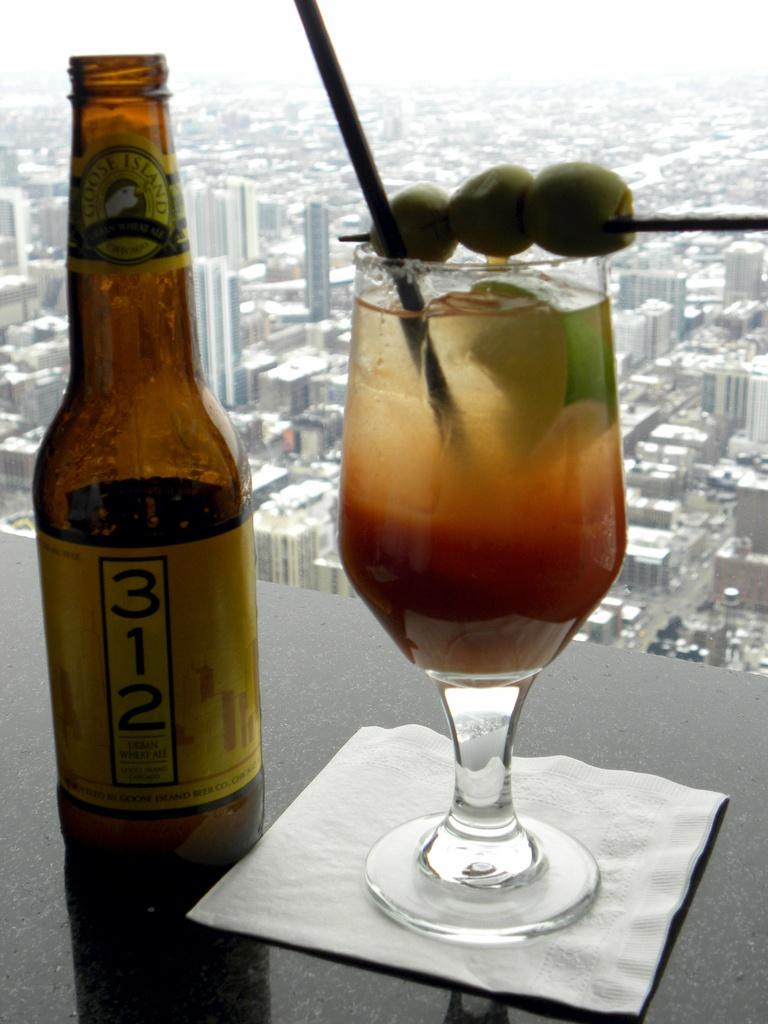<image>
Offer a succinct explanation of the picture presented. a 312 logo that is on a beer bottle 